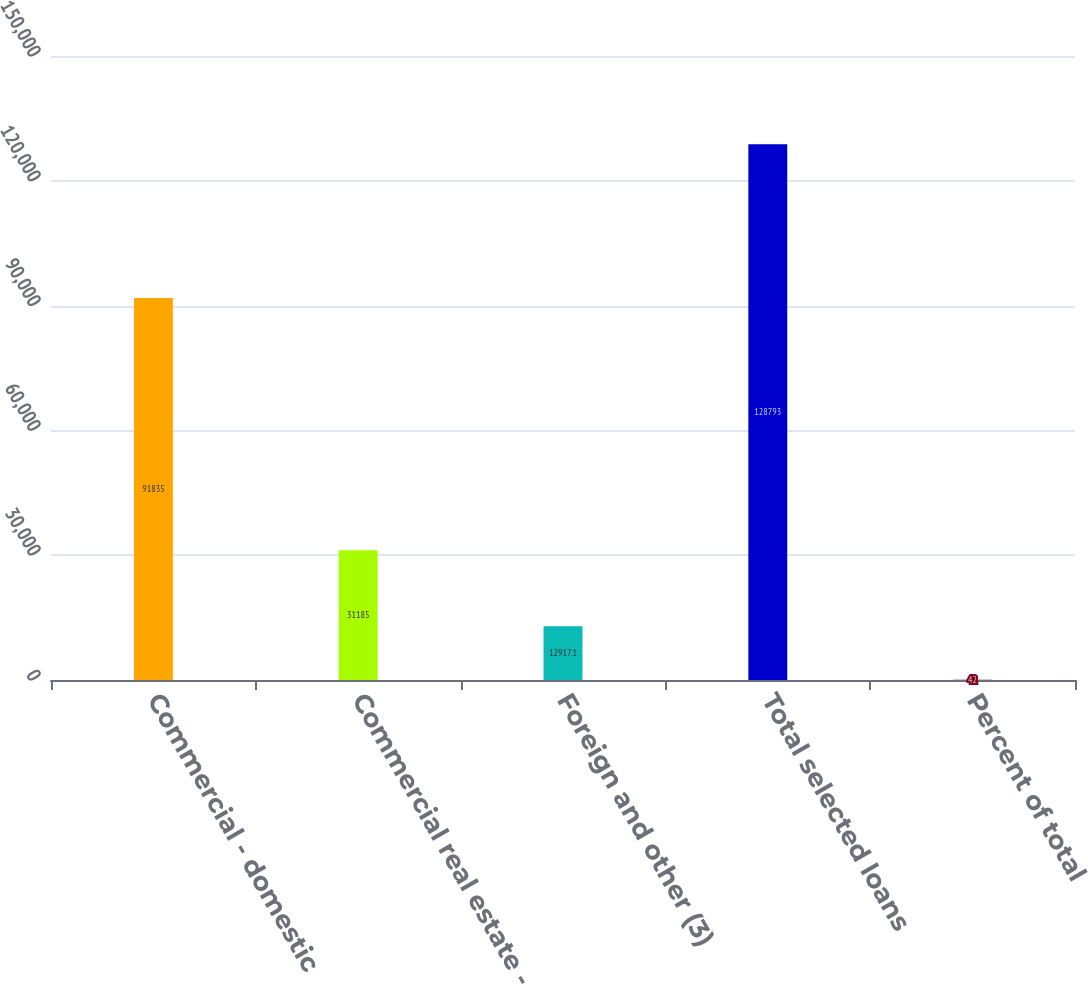Convert chart. <chart><loc_0><loc_0><loc_500><loc_500><bar_chart><fcel>Commercial - domestic<fcel>Commercial real estate -<fcel>Foreign and other (3)<fcel>Total selected loans<fcel>Percent of total<nl><fcel>91835<fcel>31185<fcel>12917.1<fcel>128793<fcel>42<nl></chart> 